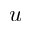<formula> <loc_0><loc_0><loc_500><loc_500>u</formula> 